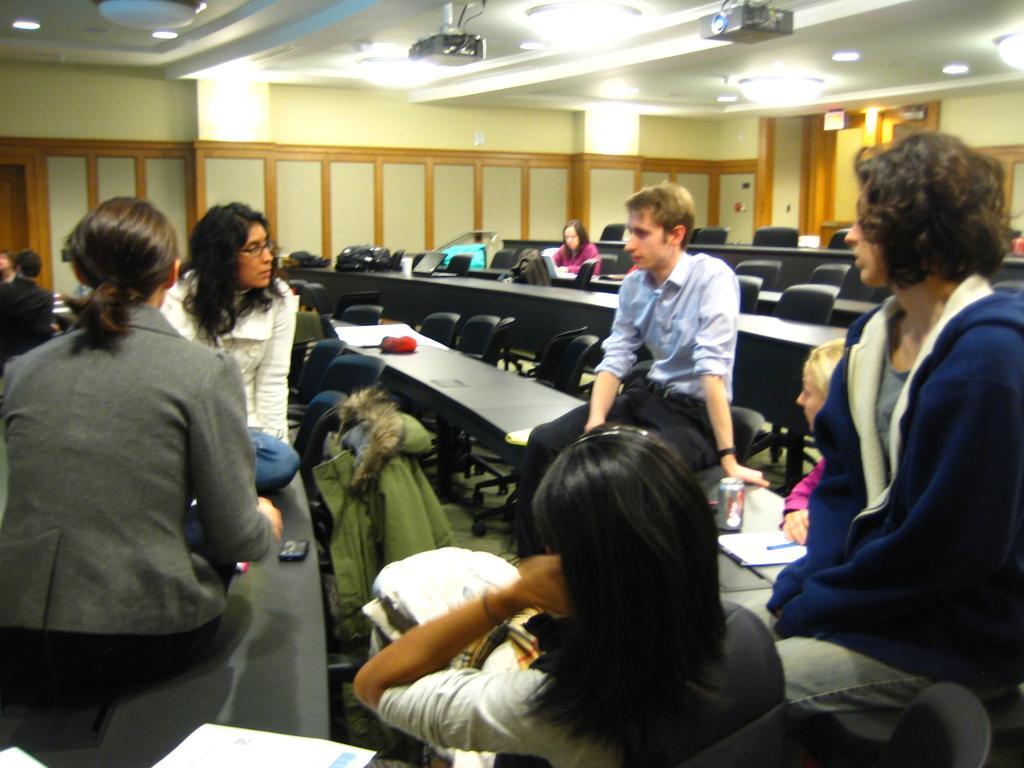Describe this image in one or two sentences. In this image I can see group of people sitting. The person in front wearing white shirt, blue color pant and the other person wearing gray color blazer. Background I can see few chairs they are in black color and I can also see two projectors and few lights, and the wall is in cream color. 